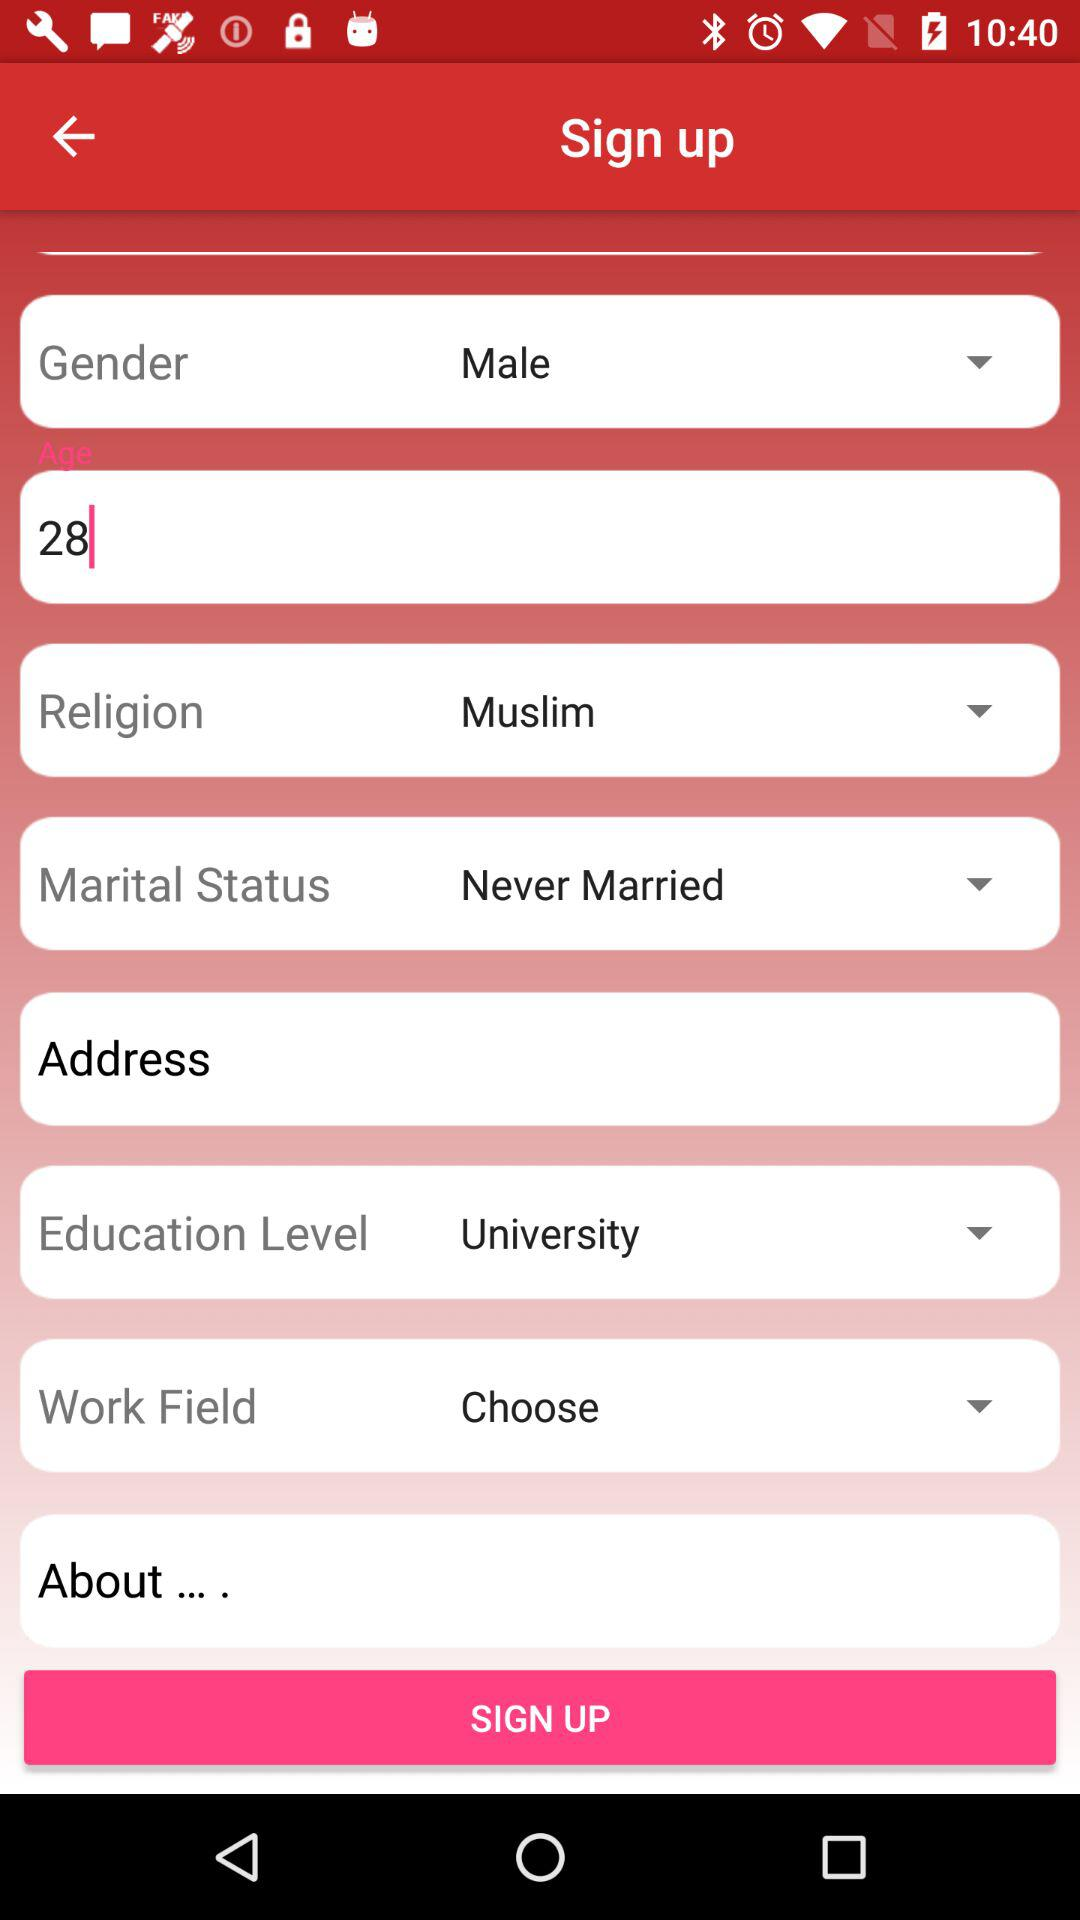Which option is selected in "Education Level"? The selected option is "University". 